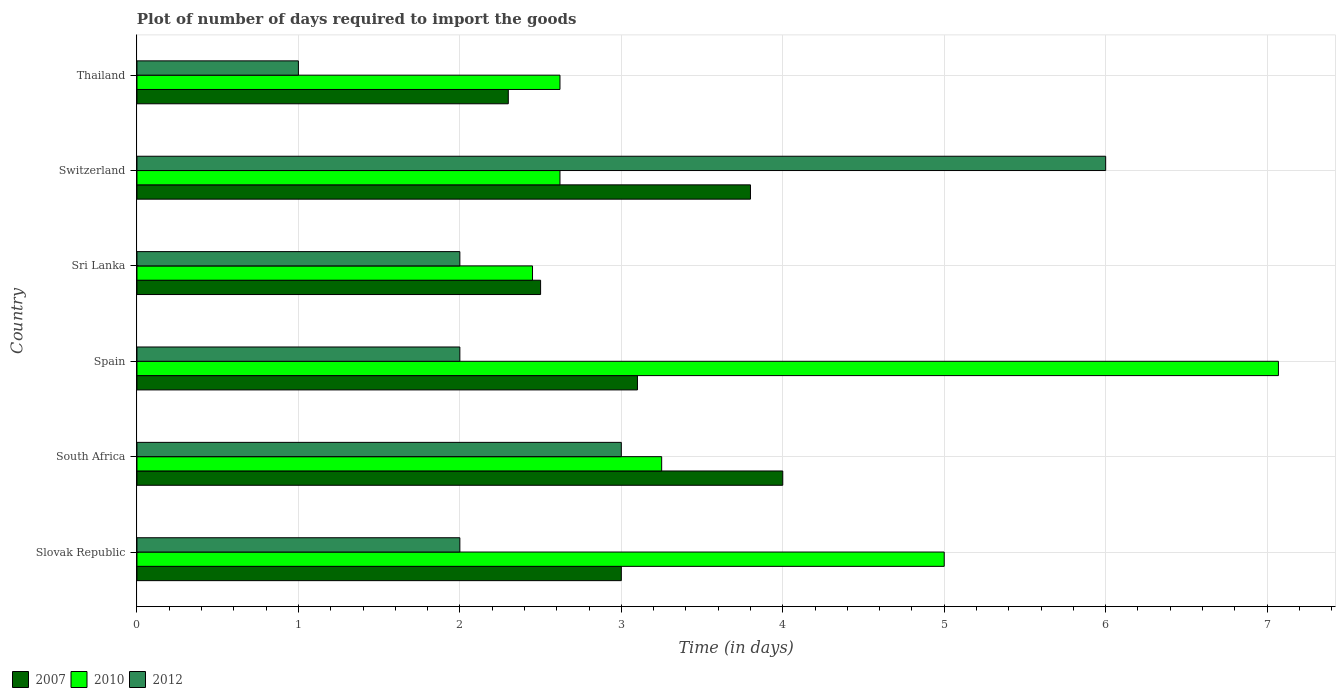How many groups of bars are there?
Offer a very short reply. 6. Are the number of bars on each tick of the Y-axis equal?
Make the answer very short. Yes. In how many cases, is the number of bars for a given country not equal to the number of legend labels?
Provide a succinct answer. 0. Across all countries, what is the minimum time required to import goods in 2007?
Keep it short and to the point. 2.3. In which country was the time required to import goods in 2007 minimum?
Your answer should be very brief. Thailand. What is the total time required to import goods in 2007 in the graph?
Give a very brief answer. 18.7. What is the difference between the time required to import goods in 2012 in South Africa and that in Spain?
Give a very brief answer. 1. What is the difference between the time required to import goods in 2012 in Thailand and the time required to import goods in 2010 in Slovak Republic?
Offer a very short reply. -4. What is the average time required to import goods in 2012 per country?
Offer a terse response. 2.67. What is the difference between the time required to import goods in 2007 and time required to import goods in 2012 in South Africa?
Your answer should be very brief. 1. Is the time required to import goods in 2010 in South Africa less than that in Thailand?
Make the answer very short. No. Is the difference between the time required to import goods in 2007 in Slovak Republic and Thailand greater than the difference between the time required to import goods in 2012 in Slovak Republic and Thailand?
Give a very brief answer. No. What is the difference between the highest and the second highest time required to import goods in 2007?
Your response must be concise. 0.2. What is the difference between the highest and the lowest time required to import goods in 2010?
Your response must be concise. 4.62. In how many countries, is the time required to import goods in 2010 greater than the average time required to import goods in 2010 taken over all countries?
Provide a succinct answer. 2. What does the 1st bar from the top in South Africa represents?
Your answer should be compact. 2012. What does the 1st bar from the bottom in Sri Lanka represents?
Give a very brief answer. 2007. Is it the case that in every country, the sum of the time required to import goods in 2010 and time required to import goods in 2007 is greater than the time required to import goods in 2012?
Provide a succinct answer. Yes. Are all the bars in the graph horizontal?
Ensure brevity in your answer.  Yes. What is the difference between two consecutive major ticks on the X-axis?
Offer a very short reply. 1. Does the graph contain any zero values?
Offer a very short reply. No. How many legend labels are there?
Offer a very short reply. 3. How are the legend labels stacked?
Offer a very short reply. Horizontal. What is the title of the graph?
Your answer should be very brief. Plot of number of days required to import the goods. What is the label or title of the X-axis?
Your answer should be very brief. Time (in days). What is the Time (in days) in 2007 in Slovak Republic?
Make the answer very short. 3. What is the Time (in days) of 2010 in Slovak Republic?
Give a very brief answer. 5. What is the Time (in days) in 2007 in South Africa?
Give a very brief answer. 4. What is the Time (in days) in 2010 in South Africa?
Provide a succinct answer. 3.25. What is the Time (in days) in 2007 in Spain?
Provide a succinct answer. 3.1. What is the Time (in days) in 2010 in Spain?
Provide a succinct answer. 7.07. What is the Time (in days) in 2007 in Sri Lanka?
Offer a very short reply. 2.5. What is the Time (in days) in 2010 in Sri Lanka?
Give a very brief answer. 2.45. What is the Time (in days) of 2007 in Switzerland?
Offer a terse response. 3.8. What is the Time (in days) in 2010 in Switzerland?
Provide a short and direct response. 2.62. What is the Time (in days) of 2012 in Switzerland?
Ensure brevity in your answer.  6. What is the Time (in days) of 2007 in Thailand?
Give a very brief answer. 2.3. What is the Time (in days) in 2010 in Thailand?
Keep it short and to the point. 2.62. What is the Time (in days) in 2012 in Thailand?
Offer a very short reply. 1. Across all countries, what is the maximum Time (in days) in 2007?
Keep it short and to the point. 4. Across all countries, what is the maximum Time (in days) in 2010?
Keep it short and to the point. 7.07. Across all countries, what is the minimum Time (in days) in 2010?
Your answer should be compact. 2.45. What is the total Time (in days) in 2010 in the graph?
Offer a terse response. 23.01. What is the total Time (in days) of 2012 in the graph?
Offer a very short reply. 16. What is the difference between the Time (in days) in 2010 in Slovak Republic and that in South Africa?
Your answer should be very brief. 1.75. What is the difference between the Time (in days) in 2010 in Slovak Republic and that in Spain?
Make the answer very short. -2.07. What is the difference between the Time (in days) of 2012 in Slovak Republic and that in Spain?
Ensure brevity in your answer.  0. What is the difference between the Time (in days) in 2007 in Slovak Republic and that in Sri Lanka?
Ensure brevity in your answer.  0.5. What is the difference between the Time (in days) of 2010 in Slovak Republic and that in Sri Lanka?
Make the answer very short. 2.55. What is the difference between the Time (in days) in 2012 in Slovak Republic and that in Sri Lanka?
Offer a very short reply. 0. What is the difference between the Time (in days) in 2010 in Slovak Republic and that in Switzerland?
Your response must be concise. 2.38. What is the difference between the Time (in days) in 2012 in Slovak Republic and that in Switzerland?
Your answer should be very brief. -4. What is the difference between the Time (in days) of 2007 in Slovak Republic and that in Thailand?
Ensure brevity in your answer.  0.7. What is the difference between the Time (in days) of 2010 in Slovak Republic and that in Thailand?
Offer a very short reply. 2.38. What is the difference between the Time (in days) in 2012 in Slovak Republic and that in Thailand?
Your answer should be very brief. 1. What is the difference between the Time (in days) of 2010 in South Africa and that in Spain?
Provide a short and direct response. -3.82. What is the difference between the Time (in days) in 2010 in South Africa and that in Sri Lanka?
Give a very brief answer. 0.8. What is the difference between the Time (in days) of 2012 in South Africa and that in Sri Lanka?
Your answer should be very brief. 1. What is the difference between the Time (in days) in 2007 in South Africa and that in Switzerland?
Your response must be concise. 0.2. What is the difference between the Time (in days) in 2010 in South Africa and that in Switzerland?
Offer a very short reply. 0.63. What is the difference between the Time (in days) in 2012 in South Africa and that in Switzerland?
Make the answer very short. -3. What is the difference between the Time (in days) in 2007 in South Africa and that in Thailand?
Offer a very short reply. 1.7. What is the difference between the Time (in days) in 2010 in South Africa and that in Thailand?
Give a very brief answer. 0.63. What is the difference between the Time (in days) in 2007 in Spain and that in Sri Lanka?
Offer a very short reply. 0.6. What is the difference between the Time (in days) in 2010 in Spain and that in Sri Lanka?
Give a very brief answer. 4.62. What is the difference between the Time (in days) in 2012 in Spain and that in Sri Lanka?
Your answer should be compact. 0. What is the difference between the Time (in days) of 2007 in Spain and that in Switzerland?
Give a very brief answer. -0.7. What is the difference between the Time (in days) of 2010 in Spain and that in Switzerland?
Ensure brevity in your answer.  4.45. What is the difference between the Time (in days) in 2010 in Spain and that in Thailand?
Your answer should be very brief. 4.45. What is the difference between the Time (in days) of 2010 in Sri Lanka and that in Switzerland?
Offer a terse response. -0.17. What is the difference between the Time (in days) of 2012 in Sri Lanka and that in Switzerland?
Provide a succinct answer. -4. What is the difference between the Time (in days) in 2007 in Sri Lanka and that in Thailand?
Keep it short and to the point. 0.2. What is the difference between the Time (in days) of 2010 in Sri Lanka and that in Thailand?
Your answer should be compact. -0.17. What is the difference between the Time (in days) in 2012 in Sri Lanka and that in Thailand?
Ensure brevity in your answer.  1. What is the difference between the Time (in days) of 2012 in Switzerland and that in Thailand?
Your answer should be very brief. 5. What is the difference between the Time (in days) of 2007 in Slovak Republic and the Time (in days) of 2012 in South Africa?
Offer a terse response. 0. What is the difference between the Time (in days) of 2007 in Slovak Republic and the Time (in days) of 2010 in Spain?
Offer a very short reply. -4.07. What is the difference between the Time (in days) of 2007 in Slovak Republic and the Time (in days) of 2012 in Spain?
Provide a short and direct response. 1. What is the difference between the Time (in days) of 2007 in Slovak Republic and the Time (in days) of 2010 in Sri Lanka?
Your answer should be very brief. 0.55. What is the difference between the Time (in days) of 2007 in Slovak Republic and the Time (in days) of 2012 in Sri Lanka?
Make the answer very short. 1. What is the difference between the Time (in days) of 2007 in Slovak Republic and the Time (in days) of 2010 in Switzerland?
Keep it short and to the point. 0.38. What is the difference between the Time (in days) in 2007 in Slovak Republic and the Time (in days) in 2012 in Switzerland?
Provide a short and direct response. -3. What is the difference between the Time (in days) of 2007 in Slovak Republic and the Time (in days) of 2010 in Thailand?
Your answer should be compact. 0.38. What is the difference between the Time (in days) in 2007 in South Africa and the Time (in days) in 2010 in Spain?
Provide a succinct answer. -3.07. What is the difference between the Time (in days) in 2007 in South Africa and the Time (in days) in 2010 in Sri Lanka?
Give a very brief answer. 1.55. What is the difference between the Time (in days) in 2007 in South Africa and the Time (in days) in 2012 in Sri Lanka?
Your answer should be very brief. 2. What is the difference between the Time (in days) of 2007 in South Africa and the Time (in days) of 2010 in Switzerland?
Ensure brevity in your answer.  1.38. What is the difference between the Time (in days) of 2010 in South Africa and the Time (in days) of 2012 in Switzerland?
Keep it short and to the point. -2.75. What is the difference between the Time (in days) in 2007 in South Africa and the Time (in days) in 2010 in Thailand?
Ensure brevity in your answer.  1.38. What is the difference between the Time (in days) in 2007 in South Africa and the Time (in days) in 2012 in Thailand?
Provide a short and direct response. 3. What is the difference between the Time (in days) of 2010 in South Africa and the Time (in days) of 2012 in Thailand?
Give a very brief answer. 2.25. What is the difference between the Time (in days) in 2007 in Spain and the Time (in days) in 2010 in Sri Lanka?
Provide a short and direct response. 0.65. What is the difference between the Time (in days) in 2007 in Spain and the Time (in days) in 2012 in Sri Lanka?
Make the answer very short. 1.1. What is the difference between the Time (in days) in 2010 in Spain and the Time (in days) in 2012 in Sri Lanka?
Give a very brief answer. 5.07. What is the difference between the Time (in days) of 2007 in Spain and the Time (in days) of 2010 in Switzerland?
Offer a terse response. 0.48. What is the difference between the Time (in days) in 2007 in Spain and the Time (in days) in 2012 in Switzerland?
Keep it short and to the point. -2.9. What is the difference between the Time (in days) of 2010 in Spain and the Time (in days) of 2012 in Switzerland?
Give a very brief answer. 1.07. What is the difference between the Time (in days) in 2007 in Spain and the Time (in days) in 2010 in Thailand?
Offer a very short reply. 0.48. What is the difference between the Time (in days) in 2007 in Spain and the Time (in days) in 2012 in Thailand?
Make the answer very short. 2.1. What is the difference between the Time (in days) of 2010 in Spain and the Time (in days) of 2012 in Thailand?
Your answer should be very brief. 6.07. What is the difference between the Time (in days) of 2007 in Sri Lanka and the Time (in days) of 2010 in Switzerland?
Your response must be concise. -0.12. What is the difference between the Time (in days) of 2007 in Sri Lanka and the Time (in days) of 2012 in Switzerland?
Provide a succinct answer. -3.5. What is the difference between the Time (in days) in 2010 in Sri Lanka and the Time (in days) in 2012 in Switzerland?
Ensure brevity in your answer.  -3.55. What is the difference between the Time (in days) in 2007 in Sri Lanka and the Time (in days) in 2010 in Thailand?
Make the answer very short. -0.12. What is the difference between the Time (in days) in 2007 in Sri Lanka and the Time (in days) in 2012 in Thailand?
Keep it short and to the point. 1.5. What is the difference between the Time (in days) in 2010 in Sri Lanka and the Time (in days) in 2012 in Thailand?
Offer a very short reply. 1.45. What is the difference between the Time (in days) in 2007 in Switzerland and the Time (in days) in 2010 in Thailand?
Give a very brief answer. 1.18. What is the difference between the Time (in days) in 2010 in Switzerland and the Time (in days) in 2012 in Thailand?
Give a very brief answer. 1.62. What is the average Time (in days) in 2007 per country?
Keep it short and to the point. 3.12. What is the average Time (in days) in 2010 per country?
Keep it short and to the point. 3.83. What is the average Time (in days) of 2012 per country?
Make the answer very short. 2.67. What is the difference between the Time (in days) in 2007 and Time (in days) in 2010 in South Africa?
Make the answer very short. 0.75. What is the difference between the Time (in days) in 2007 and Time (in days) in 2010 in Spain?
Provide a succinct answer. -3.97. What is the difference between the Time (in days) of 2007 and Time (in days) of 2012 in Spain?
Ensure brevity in your answer.  1.1. What is the difference between the Time (in days) in 2010 and Time (in days) in 2012 in Spain?
Your answer should be very brief. 5.07. What is the difference between the Time (in days) in 2007 and Time (in days) in 2010 in Sri Lanka?
Provide a short and direct response. 0.05. What is the difference between the Time (in days) in 2007 and Time (in days) in 2012 in Sri Lanka?
Give a very brief answer. 0.5. What is the difference between the Time (in days) of 2010 and Time (in days) of 2012 in Sri Lanka?
Your answer should be very brief. 0.45. What is the difference between the Time (in days) of 2007 and Time (in days) of 2010 in Switzerland?
Make the answer very short. 1.18. What is the difference between the Time (in days) of 2010 and Time (in days) of 2012 in Switzerland?
Keep it short and to the point. -3.38. What is the difference between the Time (in days) in 2007 and Time (in days) in 2010 in Thailand?
Offer a terse response. -0.32. What is the difference between the Time (in days) in 2007 and Time (in days) in 2012 in Thailand?
Make the answer very short. 1.3. What is the difference between the Time (in days) of 2010 and Time (in days) of 2012 in Thailand?
Provide a short and direct response. 1.62. What is the ratio of the Time (in days) in 2010 in Slovak Republic to that in South Africa?
Your answer should be compact. 1.54. What is the ratio of the Time (in days) of 2007 in Slovak Republic to that in Spain?
Your answer should be compact. 0.97. What is the ratio of the Time (in days) in 2010 in Slovak Republic to that in Spain?
Ensure brevity in your answer.  0.71. What is the ratio of the Time (in days) in 2010 in Slovak Republic to that in Sri Lanka?
Ensure brevity in your answer.  2.04. What is the ratio of the Time (in days) in 2007 in Slovak Republic to that in Switzerland?
Your answer should be very brief. 0.79. What is the ratio of the Time (in days) in 2010 in Slovak Republic to that in Switzerland?
Keep it short and to the point. 1.91. What is the ratio of the Time (in days) in 2012 in Slovak Republic to that in Switzerland?
Give a very brief answer. 0.33. What is the ratio of the Time (in days) of 2007 in Slovak Republic to that in Thailand?
Provide a short and direct response. 1.3. What is the ratio of the Time (in days) of 2010 in Slovak Republic to that in Thailand?
Ensure brevity in your answer.  1.91. What is the ratio of the Time (in days) of 2012 in Slovak Republic to that in Thailand?
Provide a short and direct response. 2. What is the ratio of the Time (in days) of 2007 in South Africa to that in Spain?
Make the answer very short. 1.29. What is the ratio of the Time (in days) of 2010 in South Africa to that in Spain?
Ensure brevity in your answer.  0.46. What is the ratio of the Time (in days) in 2012 in South Africa to that in Spain?
Keep it short and to the point. 1.5. What is the ratio of the Time (in days) in 2010 in South Africa to that in Sri Lanka?
Make the answer very short. 1.33. What is the ratio of the Time (in days) in 2012 in South Africa to that in Sri Lanka?
Your answer should be compact. 1.5. What is the ratio of the Time (in days) in 2007 in South Africa to that in Switzerland?
Your response must be concise. 1.05. What is the ratio of the Time (in days) of 2010 in South Africa to that in Switzerland?
Your answer should be compact. 1.24. What is the ratio of the Time (in days) of 2007 in South Africa to that in Thailand?
Provide a short and direct response. 1.74. What is the ratio of the Time (in days) of 2010 in South Africa to that in Thailand?
Make the answer very short. 1.24. What is the ratio of the Time (in days) in 2007 in Spain to that in Sri Lanka?
Keep it short and to the point. 1.24. What is the ratio of the Time (in days) in 2010 in Spain to that in Sri Lanka?
Provide a short and direct response. 2.89. What is the ratio of the Time (in days) in 2012 in Spain to that in Sri Lanka?
Your answer should be very brief. 1. What is the ratio of the Time (in days) in 2007 in Spain to that in Switzerland?
Keep it short and to the point. 0.82. What is the ratio of the Time (in days) of 2010 in Spain to that in Switzerland?
Give a very brief answer. 2.7. What is the ratio of the Time (in days) of 2012 in Spain to that in Switzerland?
Keep it short and to the point. 0.33. What is the ratio of the Time (in days) in 2007 in Spain to that in Thailand?
Keep it short and to the point. 1.35. What is the ratio of the Time (in days) of 2010 in Spain to that in Thailand?
Your answer should be compact. 2.7. What is the ratio of the Time (in days) of 2012 in Spain to that in Thailand?
Make the answer very short. 2. What is the ratio of the Time (in days) of 2007 in Sri Lanka to that in Switzerland?
Give a very brief answer. 0.66. What is the ratio of the Time (in days) of 2010 in Sri Lanka to that in Switzerland?
Provide a succinct answer. 0.94. What is the ratio of the Time (in days) in 2007 in Sri Lanka to that in Thailand?
Your response must be concise. 1.09. What is the ratio of the Time (in days) in 2010 in Sri Lanka to that in Thailand?
Offer a very short reply. 0.94. What is the ratio of the Time (in days) of 2007 in Switzerland to that in Thailand?
Provide a short and direct response. 1.65. What is the ratio of the Time (in days) of 2010 in Switzerland to that in Thailand?
Give a very brief answer. 1. What is the difference between the highest and the second highest Time (in days) of 2010?
Ensure brevity in your answer.  2.07. What is the difference between the highest and the second highest Time (in days) of 2012?
Make the answer very short. 3. What is the difference between the highest and the lowest Time (in days) in 2007?
Ensure brevity in your answer.  1.7. What is the difference between the highest and the lowest Time (in days) of 2010?
Provide a short and direct response. 4.62. 